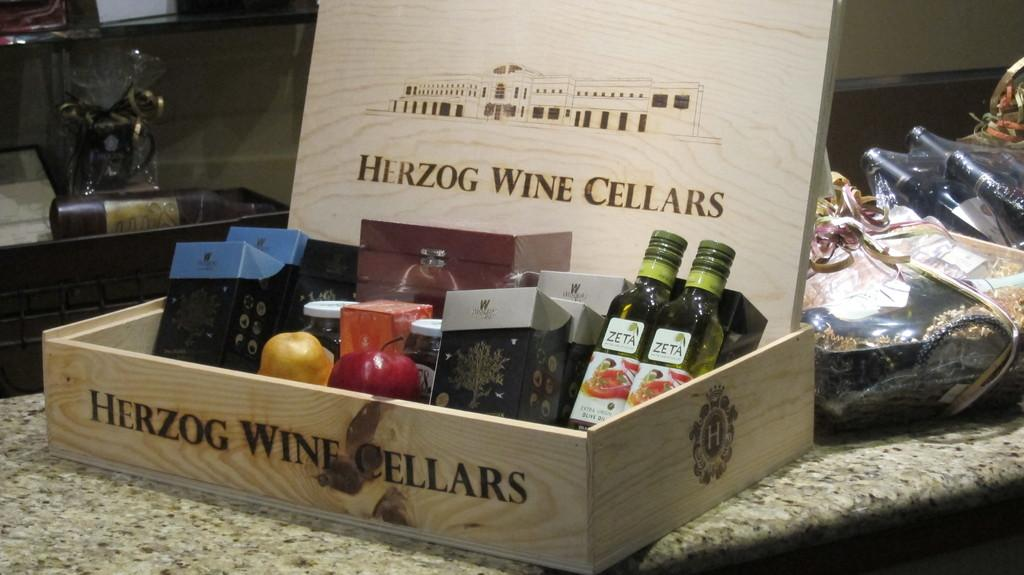<image>
Give a short and clear explanation of the subsequent image. the name Herzog is on a piece of wood 